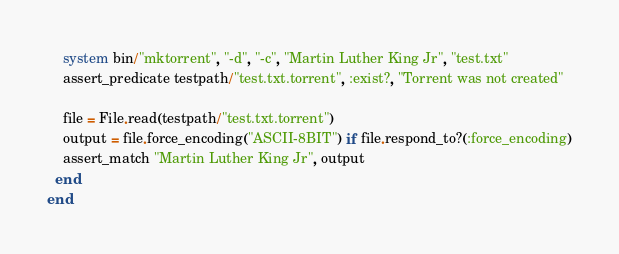Convert code to text. <code><loc_0><loc_0><loc_500><loc_500><_Ruby_>
    system bin/"mktorrent", "-d", "-c", "Martin Luther King Jr", "test.txt"
    assert_predicate testpath/"test.txt.torrent", :exist?, "Torrent was not created"

    file = File.read(testpath/"test.txt.torrent")
    output = file.force_encoding("ASCII-8BIT") if file.respond_to?(:force_encoding)
    assert_match "Martin Luther King Jr", output
  end
end
</code> 